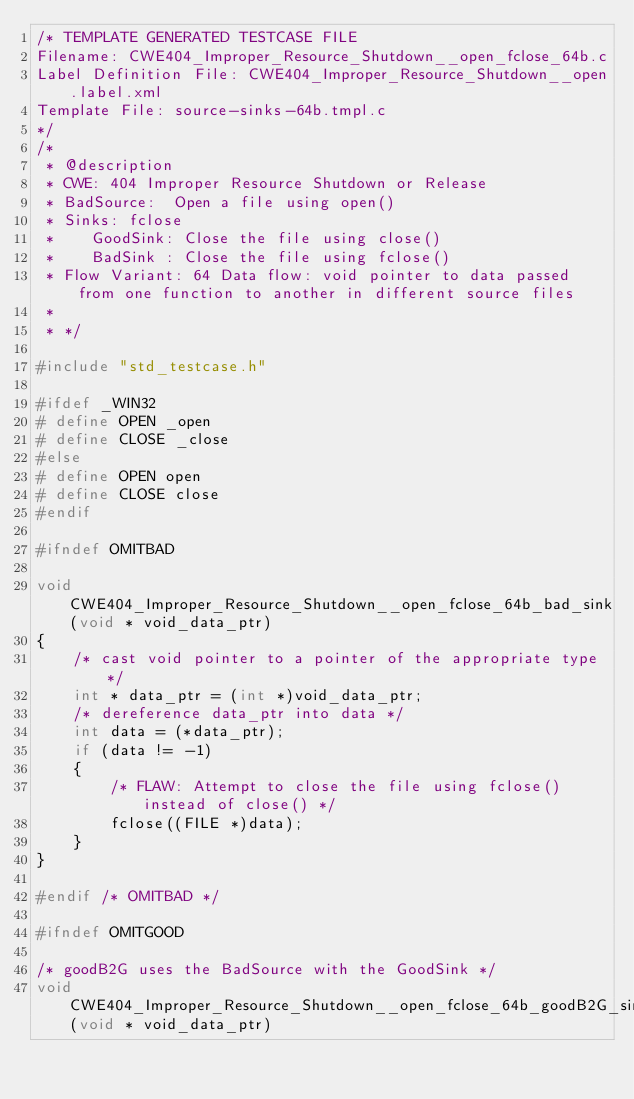Convert code to text. <code><loc_0><loc_0><loc_500><loc_500><_C_>/* TEMPLATE GENERATED TESTCASE FILE
Filename: CWE404_Improper_Resource_Shutdown__open_fclose_64b.c
Label Definition File: CWE404_Improper_Resource_Shutdown__open.label.xml
Template File: source-sinks-64b.tmpl.c
*/
/*
 * @description
 * CWE: 404 Improper Resource Shutdown or Release
 * BadSource:  Open a file using open()
 * Sinks: fclose
 *    GoodSink: Close the file using close()
 *    BadSink : Close the file using fclose()
 * Flow Variant: 64 Data flow: void pointer to data passed from one function to another in different source files
 *
 * */

#include "std_testcase.h"

#ifdef _WIN32
# define OPEN _open
# define CLOSE _close
#else
# define OPEN open
# define CLOSE close
#endif

#ifndef OMITBAD

void CWE404_Improper_Resource_Shutdown__open_fclose_64b_bad_sink(void * void_data_ptr)
{
    /* cast void pointer to a pointer of the appropriate type */
    int * data_ptr = (int *)void_data_ptr;
    /* dereference data_ptr into data */
    int data = (*data_ptr);
    if (data != -1)
    {
        /* FLAW: Attempt to close the file using fclose() instead of close() */
        fclose((FILE *)data);
    }
}

#endif /* OMITBAD */

#ifndef OMITGOOD

/* goodB2G uses the BadSource with the GoodSink */
void CWE404_Improper_Resource_Shutdown__open_fclose_64b_goodB2G_sink(void * void_data_ptr)</code> 